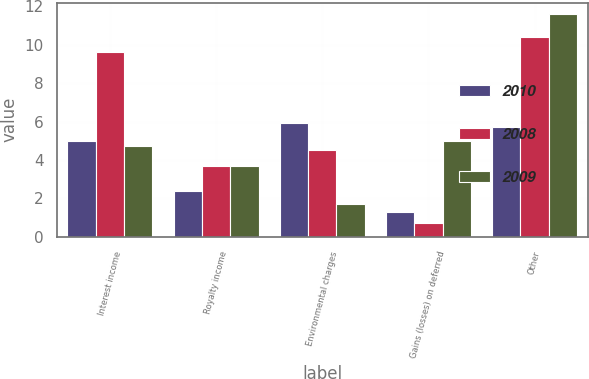Convert chart. <chart><loc_0><loc_0><loc_500><loc_500><stacked_bar_chart><ecel><fcel>Interest income<fcel>Royalty income<fcel>Environmental charges<fcel>Gains (losses) on deferred<fcel>Other<nl><fcel>2010<fcel>5<fcel>2.4<fcel>5.9<fcel>1.3<fcel>5.7<nl><fcel>2008<fcel>9.6<fcel>3.7<fcel>4.5<fcel>0.7<fcel>10.4<nl><fcel>2009<fcel>4.75<fcel>3.7<fcel>1.7<fcel>5<fcel>11.6<nl></chart> 